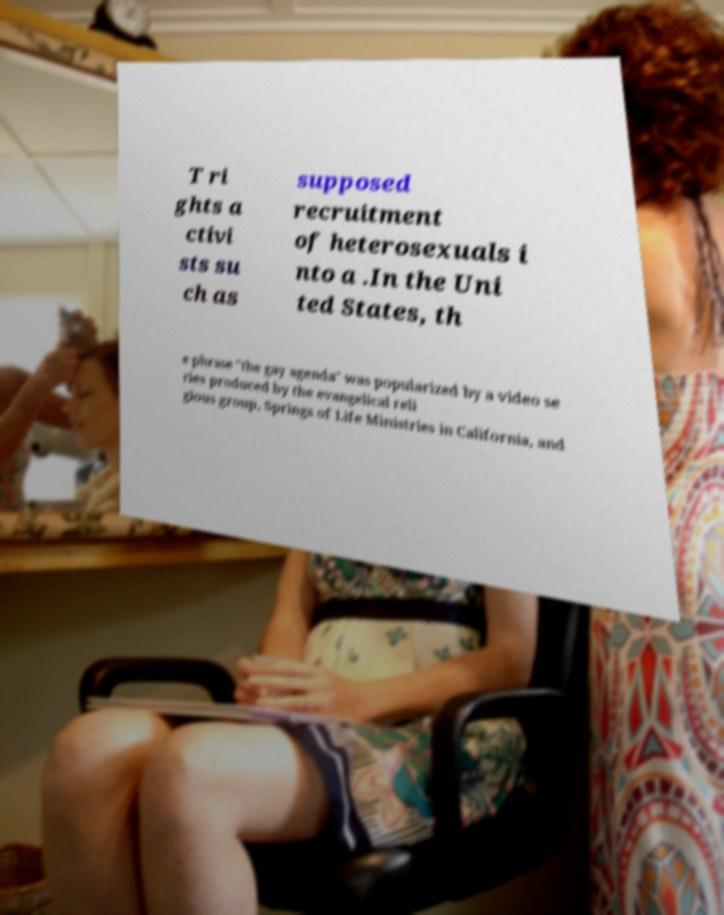What messages or text are displayed in this image? I need them in a readable, typed format. T ri ghts a ctivi sts su ch as supposed recruitment of heterosexuals i nto a .In the Uni ted States, th e phrase "the gay agenda" was popularized by a video se ries produced by the evangelical reli gious group, Springs of Life Ministries in California, and 